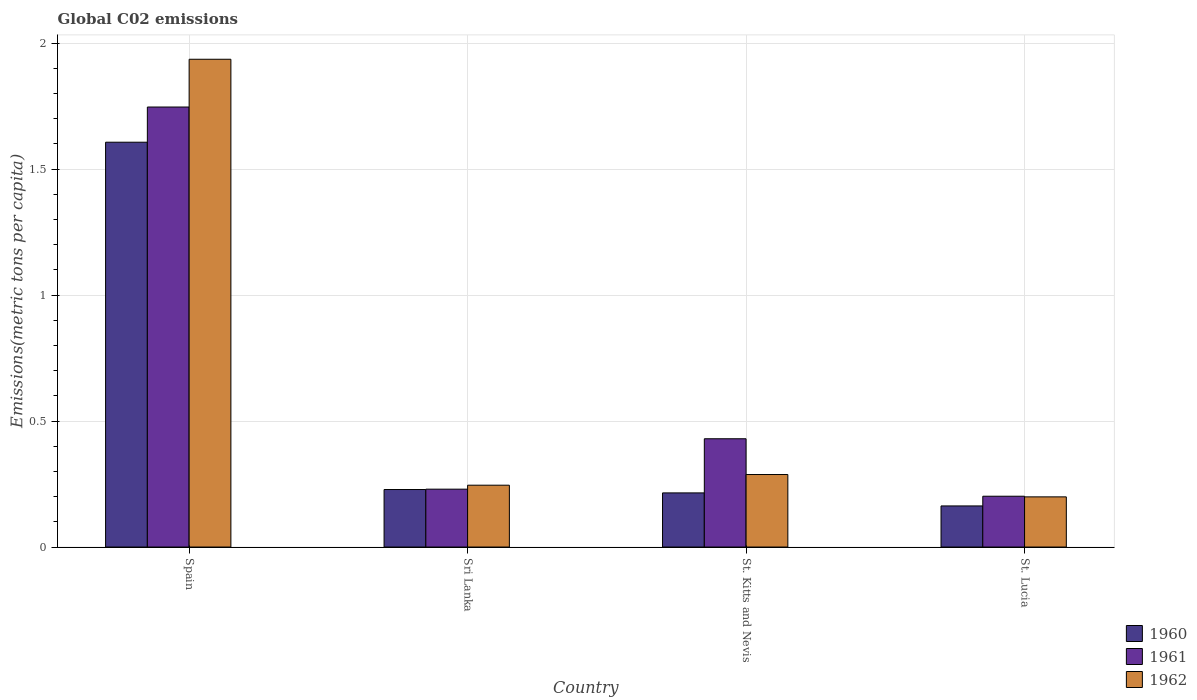How many different coloured bars are there?
Provide a short and direct response. 3. How many groups of bars are there?
Your answer should be compact. 4. How many bars are there on the 3rd tick from the right?
Offer a very short reply. 3. What is the label of the 2nd group of bars from the left?
Your answer should be very brief. Sri Lanka. What is the amount of CO2 emitted in in 1961 in Spain?
Offer a very short reply. 1.75. Across all countries, what is the maximum amount of CO2 emitted in in 1962?
Provide a short and direct response. 1.94. Across all countries, what is the minimum amount of CO2 emitted in in 1962?
Your answer should be very brief. 0.2. In which country was the amount of CO2 emitted in in 1960 maximum?
Your response must be concise. Spain. In which country was the amount of CO2 emitted in in 1961 minimum?
Provide a short and direct response. St. Lucia. What is the total amount of CO2 emitted in in 1962 in the graph?
Your answer should be very brief. 2.67. What is the difference between the amount of CO2 emitted in in 1962 in Spain and that in St. Lucia?
Give a very brief answer. 1.74. What is the difference between the amount of CO2 emitted in in 1962 in Spain and the amount of CO2 emitted in in 1960 in St. Kitts and Nevis?
Your answer should be compact. 1.72. What is the average amount of CO2 emitted in in 1961 per country?
Provide a short and direct response. 0.65. What is the difference between the amount of CO2 emitted in of/in 1962 and amount of CO2 emitted in of/in 1961 in St. Lucia?
Offer a terse response. -0. In how many countries, is the amount of CO2 emitted in in 1962 greater than 1.4 metric tons per capita?
Provide a short and direct response. 1. What is the ratio of the amount of CO2 emitted in in 1962 in Sri Lanka to that in St. Lucia?
Provide a short and direct response. 1.23. Is the amount of CO2 emitted in in 1961 in Spain less than that in Sri Lanka?
Your answer should be compact. No. Is the difference between the amount of CO2 emitted in in 1962 in Spain and St. Lucia greater than the difference between the amount of CO2 emitted in in 1961 in Spain and St. Lucia?
Provide a succinct answer. Yes. What is the difference between the highest and the second highest amount of CO2 emitted in in 1960?
Provide a short and direct response. -1.38. What is the difference between the highest and the lowest amount of CO2 emitted in in 1961?
Offer a very short reply. 1.54. What does the 1st bar from the right in Spain represents?
Keep it short and to the point. 1962. Is it the case that in every country, the sum of the amount of CO2 emitted in in 1960 and amount of CO2 emitted in in 1962 is greater than the amount of CO2 emitted in in 1961?
Ensure brevity in your answer.  Yes. How many bars are there?
Ensure brevity in your answer.  12. How many countries are there in the graph?
Your answer should be very brief. 4. Does the graph contain any zero values?
Your answer should be very brief. No. How are the legend labels stacked?
Your response must be concise. Vertical. What is the title of the graph?
Offer a very short reply. Global C02 emissions. Does "1998" appear as one of the legend labels in the graph?
Make the answer very short. No. What is the label or title of the Y-axis?
Provide a short and direct response. Emissions(metric tons per capita). What is the Emissions(metric tons per capita) of 1960 in Spain?
Your answer should be very brief. 1.61. What is the Emissions(metric tons per capita) in 1961 in Spain?
Your response must be concise. 1.75. What is the Emissions(metric tons per capita) of 1962 in Spain?
Ensure brevity in your answer.  1.94. What is the Emissions(metric tons per capita) of 1960 in Sri Lanka?
Your answer should be compact. 0.23. What is the Emissions(metric tons per capita) in 1961 in Sri Lanka?
Your response must be concise. 0.23. What is the Emissions(metric tons per capita) in 1962 in Sri Lanka?
Offer a very short reply. 0.25. What is the Emissions(metric tons per capita) of 1960 in St. Kitts and Nevis?
Provide a succinct answer. 0.21. What is the Emissions(metric tons per capita) of 1961 in St. Kitts and Nevis?
Offer a terse response. 0.43. What is the Emissions(metric tons per capita) of 1962 in St. Kitts and Nevis?
Make the answer very short. 0.29. What is the Emissions(metric tons per capita) of 1960 in St. Lucia?
Provide a succinct answer. 0.16. What is the Emissions(metric tons per capita) in 1961 in St. Lucia?
Keep it short and to the point. 0.2. What is the Emissions(metric tons per capita) of 1962 in St. Lucia?
Provide a short and direct response. 0.2. Across all countries, what is the maximum Emissions(metric tons per capita) in 1960?
Your answer should be very brief. 1.61. Across all countries, what is the maximum Emissions(metric tons per capita) of 1961?
Provide a succinct answer. 1.75. Across all countries, what is the maximum Emissions(metric tons per capita) in 1962?
Offer a very short reply. 1.94. Across all countries, what is the minimum Emissions(metric tons per capita) in 1960?
Give a very brief answer. 0.16. Across all countries, what is the minimum Emissions(metric tons per capita) in 1961?
Provide a succinct answer. 0.2. Across all countries, what is the minimum Emissions(metric tons per capita) of 1962?
Your answer should be compact. 0.2. What is the total Emissions(metric tons per capita) of 1960 in the graph?
Offer a terse response. 2.21. What is the total Emissions(metric tons per capita) of 1961 in the graph?
Ensure brevity in your answer.  2.61. What is the total Emissions(metric tons per capita) in 1962 in the graph?
Offer a terse response. 2.67. What is the difference between the Emissions(metric tons per capita) of 1960 in Spain and that in Sri Lanka?
Keep it short and to the point. 1.38. What is the difference between the Emissions(metric tons per capita) in 1961 in Spain and that in Sri Lanka?
Provide a succinct answer. 1.52. What is the difference between the Emissions(metric tons per capita) of 1962 in Spain and that in Sri Lanka?
Provide a succinct answer. 1.69. What is the difference between the Emissions(metric tons per capita) in 1960 in Spain and that in St. Kitts and Nevis?
Provide a succinct answer. 1.39. What is the difference between the Emissions(metric tons per capita) of 1961 in Spain and that in St. Kitts and Nevis?
Give a very brief answer. 1.32. What is the difference between the Emissions(metric tons per capita) in 1962 in Spain and that in St. Kitts and Nevis?
Your answer should be compact. 1.65. What is the difference between the Emissions(metric tons per capita) in 1960 in Spain and that in St. Lucia?
Keep it short and to the point. 1.44. What is the difference between the Emissions(metric tons per capita) of 1961 in Spain and that in St. Lucia?
Make the answer very short. 1.54. What is the difference between the Emissions(metric tons per capita) of 1962 in Spain and that in St. Lucia?
Provide a succinct answer. 1.74. What is the difference between the Emissions(metric tons per capita) of 1960 in Sri Lanka and that in St. Kitts and Nevis?
Your answer should be compact. 0.01. What is the difference between the Emissions(metric tons per capita) of 1961 in Sri Lanka and that in St. Kitts and Nevis?
Offer a terse response. -0.2. What is the difference between the Emissions(metric tons per capita) in 1962 in Sri Lanka and that in St. Kitts and Nevis?
Make the answer very short. -0.04. What is the difference between the Emissions(metric tons per capita) in 1960 in Sri Lanka and that in St. Lucia?
Provide a succinct answer. 0.07. What is the difference between the Emissions(metric tons per capita) in 1961 in Sri Lanka and that in St. Lucia?
Give a very brief answer. 0.03. What is the difference between the Emissions(metric tons per capita) in 1962 in Sri Lanka and that in St. Lucia?
Keep it short and to the point. 0.05. What is the difference between the Emissions(metric tons per capita) of 1960 in St. Kitts and Nevis and that in St. Lucia?
Give a very brief answer. 0.05. What is the difference between the Emissions(metric tons per capita) of 1961 in St. Kitts and Nevis and that in St. Lucia?
Offer a very short reply. 0.23. What is the difference between the Emissions(metric tons per capita) in 1962 in St. Kitts and Nevis and that in St. Lucia?
Offer a very short reply. 0.09. What is the difference between the Emissions(metric tons per capita) of 1960 in Spain and the Emissions(metric tons per capita) of 1961 in Sri Lanka?
Your answer should be compact. 1.38. What is the difference between the Emissions(metric tons per capita) in 1960 in Spain and the Emissions(metric tons per capita) in 1962 in Sri Lanka?
Give a very brief answer. 1.36. What is the difference between the Emissions(metric tons per capita) of 1961 in Spain and the Emissions(metric tons per capita) of 1962 in Sri Lanka?
Keep it short and to the point. 1.5. What is the difference between the Emissions(metric tons per capita) in 1960 in Spain and the Emissions(metric tons per capita) in 1961 in St. Kitts and Nevis?
Give a very brief answer. 1.18. What is the difference between the Emissions(metric tons per capita) of 1960 in Spain and the Emissions(metric tons per capita) of 1962 in St. Kitts and Nevis?
Your answer should be very brief. 1.32. What is the difference between the Emissions(metric tons per capita) of 1961 in Spain and the Emissions(metric tons per capita) of 1962 in St. Kitts and Nevis?
Your answer should be compact. 1.46. What is the difference between the Emissions(metric tons per capita) of 1960 in Spain and the Emissions(metric tons per capita) of 1961 in St. Lucia?
Your answer should be compact. 1.4. What is the difference between the Emissions(metric tons per capita) in 1960 in Spain and the Emissions(metric tons per capita) in 1962 in St. Lucia?
Give a very brief answer. 1.41. What is the difference between the Emissions(metric tons per capita) of 1961 in Spain and the Emissions(metric tons per capita) of 1962 in St. Lucia?
Make the answer very short. 1.55. What is the difference between the Emissions(metric tons per capita) in 1960 in Sri Lanka and the Emissions(metric tons per capita) in 1961 in St. Kitts and Nevis?
Provide a succinct answer. -0.2. What is the difference between the Emissions(metric tons per capita) in 1960 in Sri Lanka and the Emissions(metric tons per capita) in 1962 in St. Kitts and Nevis?
Your response must be concise. -0.06. What is the difference between the Emissions(metric tons per capita) of 1961 in Sri Lanka and the Emissions(metric tons per capita) of 1962 in St. Kitts and Nevis?
Offer a terse response. -0.06. What is the difference between the Emissions(metric tons per capita) of 1960 in Sri Lanka and the Emissions(metric tons per capita) of 1961 in St. Lucia?
Ensure brevity in your answer.  0.03. What is the difference between the Emissions(metric tons per capita) in 1960 in Sri Lanka and the Emissions(metric tons per capita) in 1962 in St. Lucia?
Offer a terse response. 0.03. What is the difference between the Emissions(metric tons per capita) in 1961 in Sri Lanka and the Emissions(metric tons per capita) in 1962 in St. Lucia?
Offer a terse response. 0.03. What is the difference between the Emissions(metric tons per capita) of 1960 in St. Kitts and Nevis and the Emissions(metric tons per capita) of 1961 in St. Lucia?
Your response must be concise. 0.01. What is the difference between the Emissions(metric tons per capita) of 1960 in St. Kitts and Nevis and the Emissions(metric tons per capita) of 1962 in St. Lucia?
Offer a terse response. 0.02. What is the difference between the Emissions(metric tons per capita) of 1961 in St. Kitts and Nevis and the Emissions(metric tons per capita) of 1962 in St. Lucia?
Provide a short and direct response. 0.23. What is the average Emissions(metric tons per capita) in 1960 per country?
Provide a short and direct response. 0.55. What is the average Emissions(metric tons per capita) of 1961 per country?
Make the answer very short. 0.65. What is the average Emissions(metric tons per capita) in 1962 per country?
Provide a short and direct response. 0.67. What is the difference between the Emissions(metric tons per capita) of 1960 and Emissions(metric tons per capita) of 1961 in Spain?
Provide a short and direct response. -0.14. What is the difference between the Emissions(metric tons per capita) of 1960 and Emissions(metric tons per capita) of 1962 in Spain?
Provide a short and direct response. -0.33. What is the difference between the Emissions(metric tons per capita) of 1961 and Emissions(metric tons per capita) of 1962 in Spain?
Your response must be concise. -0.19. What is the difference between the Emissions(metric tons per capita) of 1960 and Emissions(metric tons per capita) of 1961 in Sri Lanka?
Provide a short and direct response. -0. What is the difference between the Emissions(metric tons per capita) in 1960 and Emissions(metric tons per capita) in 1962 in Sri Lanka?
Offer a terse response. -0.02. What is the difference between the Emissions(metric tons per capita) of 1961 and Emissions(metric tons per capita) of 1962 in Sri Lanka?
Provide a short and direct response. -0.02. What is the difference between the Emissions(metric tons per capita) of 1960 and Emissions(metric tons per capita) of 1961 in St. Kitts and Nevis?
Your answer should be very brief. -0.21. What is the difference between the Emissions(metric tons per capita) in 1960 and Emissions(metric tons per capita) in 1962 in St. Kitts and Nevis?
Your answer should be very brief. -0.07. What is the difference between the Emissions(metric tons per capita) of 1961 and Emissions(metric tons per capita) of 1962 in St. Kitts and Nevis?
Make the answer very short. 0.14. What is the difference between the Emissions(metric tons per capita) of 1960 and Emissions(metric tons per capita) of 1961 in St. Lucia?
Offer a very short reply. -0.04. What is the difference between the Emissions(metric tons per capita) of 1960 and Emissions(metric tons per capita) of 1962 in St. Lucia?
Your answer should be very brief. -0.04. What is the difference between the Emissions(metric tons per capita) in 1961 and Emissions(metric tons per capita) in 1962 in St. Lucia?
Offer a very short reply. 0. What is the ratio of the Emissions(metric tons per capita) in 1960 in Spain to that in Sri Lanka?
Give a very brief answer. 7.04. What is the ratio of the Emissions(metric tons per capita) of 1961 in Spain to that in Sri Lanka?
Your answer should be compact. 7.6. What is the ratio of the Emissions(metric tons per capita) in 1962 in Spain to that in Sri Lanka?
Ensure brevity in your answer.  7.89. What is the ratio of the Emissions(metric tons per capita) in 1960 in Spain to that in St. Kitts and Nevis?
Give a very brief answer. 7.48. What is the ratio of the Emissions(metric tons per capita) of 1961 in Spain to that in St. Kitts and Nevis?
Your answer should be very brief. 4.06. What is the ratio of the Emissions(metric tons per capita) in 1962 in Spain to that in St. Kitts and Nevis?
Make the answer very short. 6.73. What is the ratio of the Emissions(metric tons per capita) of 1960 in Spain to that in St. Lucia?
Your answer should be very brief. 9.85. What is the ratio of the Emissions(metric tons per capita) in 1961 in Spain to that in St. Lucia?
Your answer should be very brief. 8.66. What is the ratio of the Emissions(metric tons per capita) in 1962 in Spain to that in St. Lucia?
Offer a terse response. 9.72. What is the ratio of the Emissions(metric tons per capita) in 1960 in Sri Lanka to that in St. Kitts and Nevis?
Provide a succinct answer. 1.06. What is the ratio of the Emissions(metric tons per capita) in 1961 in Sri Lanka to that in St. Kitts and Nevis?
Your answer should be very brief. 0.53. What is the ratio of the Emissions(metric tons per capita) of 1962 in Sri Lanka to that in St. Kitts and Nevis?
Offer a terse response. 0.85. What is the ratio of the Emissions(metric tons per capita) in 1960 in Sri Lanka to that in St. Lucia?
Your answer should be compact. 1.4. What is the ratio of the Emissions(metric tons per capita) in 1961 in Sri Lanka to that in St. Lucia?
Offer a terse response. 1.14. What is the ratio of the Emissions(metric tons per capita) of 1962 in Sri Lanka to that in St. Lucia?
Offer a very short reply. 1.23. What is the ratio of the Emissions(metric tons per capita) of 1960 in St. Kitts and Nevis to that in St. Lucia?
Give a very brief answer. 1.32. What is the ratio of the Emissions(metric tons per capita) in 1961 in St. Kitts and Nevis to that in St. Lucia?
Offer a very short reply. 2.13. What is the ratio of the Emissions(metric tons per capita) in 1962 in St. Kitts and Nevis to that in St. Lucia?
Your response must be concise. 1.45. What is the difference between the highest and the second highest Emissions(metric tons per capita) in 1960?
Provide a succinct answer. 1.38. What is the difference between the highest and the second highest Emissions(metric tons per capita) of 1961?
Provide a succinct answer. 1.32. What is the difference between the highest and the second highest Emissions(metric tons per capita) of 1962?
Give a very brief answer. 1.65. What is the difference between the highest and the lowest Emissions(metric tons per capita) of 1960?
Offer a terse response. 1.44. What is the difference between the highest and the lowest Emissions(metric tons per capita) of 1961?
Give a very brief answer. 1.54. What is the difference between the highest and the lowest Emissions(metric tons per capita) in 1962?
Offer a terse response. 1.74. 